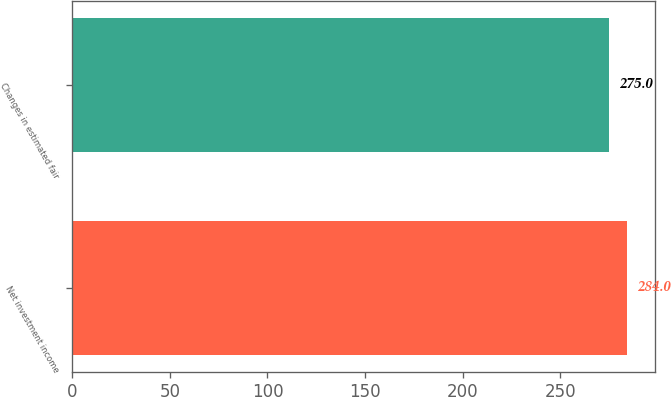Convert chart to OTSL. <chart><loc_0><loc_0><loc_500><loc_500><bar_chart><fcel>Net investment income<fcel>Changes in estimated fair<nl><fcel>284<fcel>275<nl></chart> 